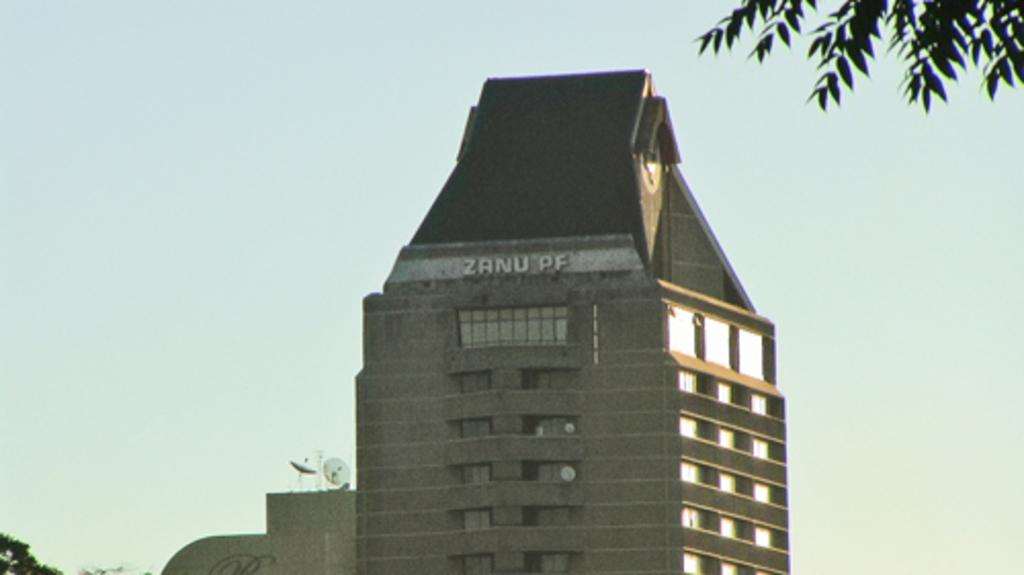What type of structure is in the image? There is a tower building in the image. What other elements can be seen in the image? There are trees in the image. What can be seen in the background of the image? The sky is visible in the background of the image, and it appears to be plain. How fast is the calculator running in the image? There is no calculator present in the image, so it cannot be determined how fast it might be running. 